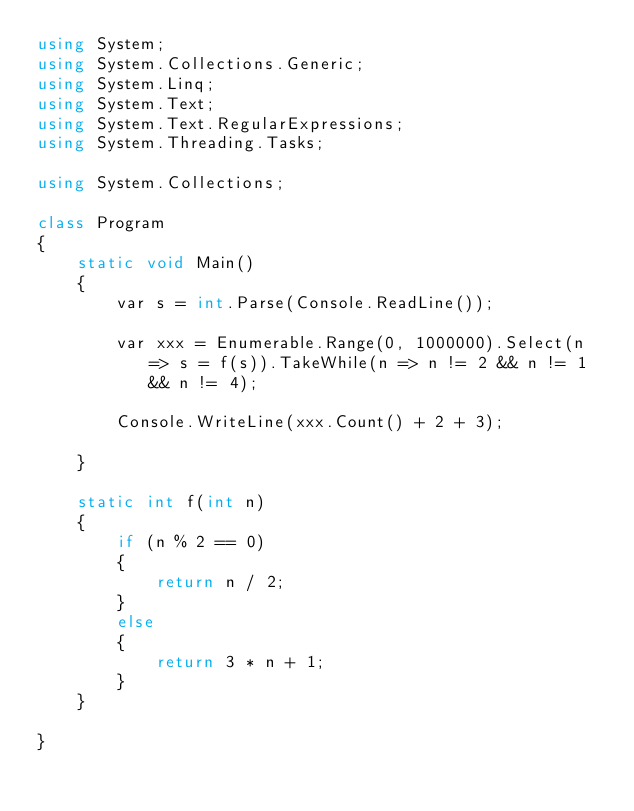Convert code to text. <code><loc_0><loc_0><loc_500><loc_500><_C#_>using System;
using System.Collections.Generic;
using System.Linq;
using System.Text;
using System.Text.RegularExpressions;
using System.Threading.Tasks;

using System.Collections;

class Program
{
    static void Main()
    {
        var s = int.Parse(Console.ReadLine());

        var xxx = Enumerable.Range(0, 1000000).Select(n => s = f(s)).TakeWhile(n => n != 2 && n != 1 && n != 4);

        Console.WriteLine(xxx.Count() + 2 + 3);

    }

    static int f(int n)
    {
        if (n % 2 == 0)
        {
            return n / 2;
        }
        else
        {
            return 3 * n + 1;
        }
    }
    
}
</code> 